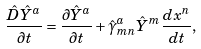Convert formula to latex. <formula><loc_0><loc_0><loc_500><loc_500>\frac { \hat { D } \hat { Y } ^ { a } } { \partial t } = \frac { \partial \hat { Y } ^ { a } } { \partial t } + \hat { \gamma } ^ { a } _ { m n } \hat { Y } ^ { m } \frac { d x ^ { n } } { d t } ,</formula> 